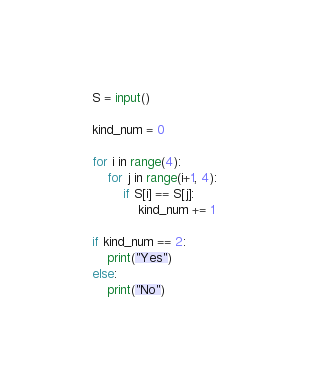<code> <loc_0><loc_0><loc_500><loc_500><_Python_>S = input()

kind_num = 0

for i in range(4):
    for j in range(i+1, 4):
        if S[i] == S[j]:
            kind_num += 1

if kind_num == 2:
    print("Yes")
else:
    print("No")</code> 